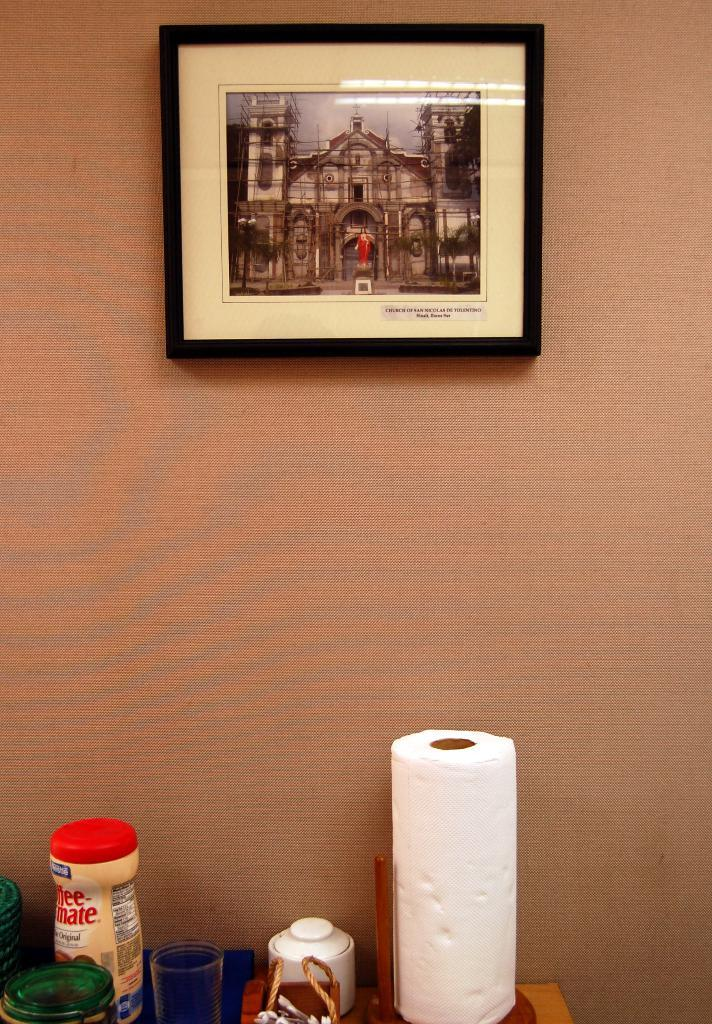What is present on the wall in the image? There is a photo frame on the wall. What can be seen in the photo inside the frame? The photo contains a building, a statue, and trees. What is the primary purpose of the photo frame? The photo frame is used to display the photo. What objects are present on a surface at the bottom of the image? The information provided does not specify the objects on the surface. How many patches are visible on the quilt in the image? There is no quilt present in the image. Is the person in the photo sleeping or awake? The image does not contain a person, so it is impossible to determine if they are sleeping or awake. 